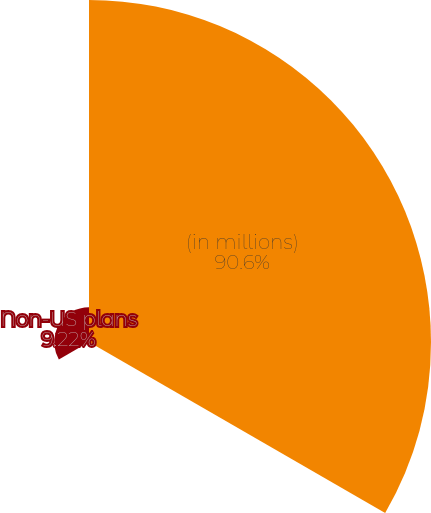Convert chart to OTSL. <chart><loc_0><loc_0><loc_500><loc_500><pie_chart><fcel>(in millions)<fcel>US plans<fcel>Non-US plans<nl><fcel>90.6%<fcel>0.18%<fcel>9.22%<nl></chart> 